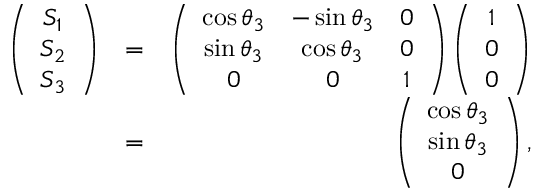<formula> <loc_0><loc_0><loc_500><loc_500>\begin{array} { r l r } { \left ( \begin{array} { c } { S _ { 1 } } \\ { S _ { 2 } } \\ { S _ { 3 } } \end{array} \right ) } & { = } & { \left ( \begin{array} { c c c } { \cos \theta _ { 3 } } & { - \sin \theta _ { 3 } } & { 0 } \\ { \sin \theta _ { 3 } } & { \cos \theta _ { 3 } } & { 0 } \\ { 0 } & { 0 } & { 1 } \end{array} \right ) \left ( \begin{array} { c } { 1 } \\ { 0 } \\ { 0 } \end{array} \right ) } \\ & { = } & { \left ( \begin{array} { c } { \cos \theta _ { 3 } } \\ { \sin \theta _ { 3 } } \\ { 0 } \end{array} \right ) , } \end{array}</formula> 